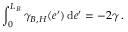<formula> <loc_0><loc_0><loc_500><loc_500>\int _ { 0 } ^ { L _ { B } } \gamma _ { B , H } ( e ^ { \prime } ) \, d e ^ { \prime } = - 2 \gamma \, .</formula> 